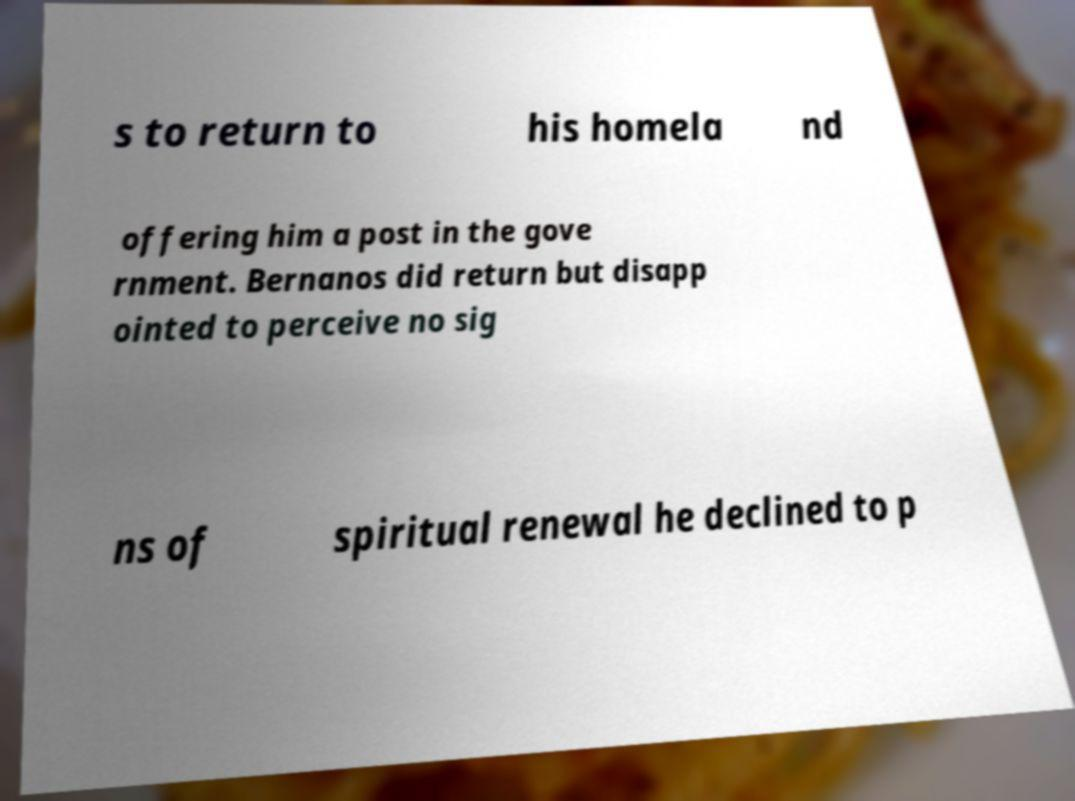I need the written content from this picture converted into text. Can you do that? s to return to his homela nd offering him a post in the gove rnment. Bernanos did return but disapp ointed to perceive no sig ns of spiritual renewal he declined to p 